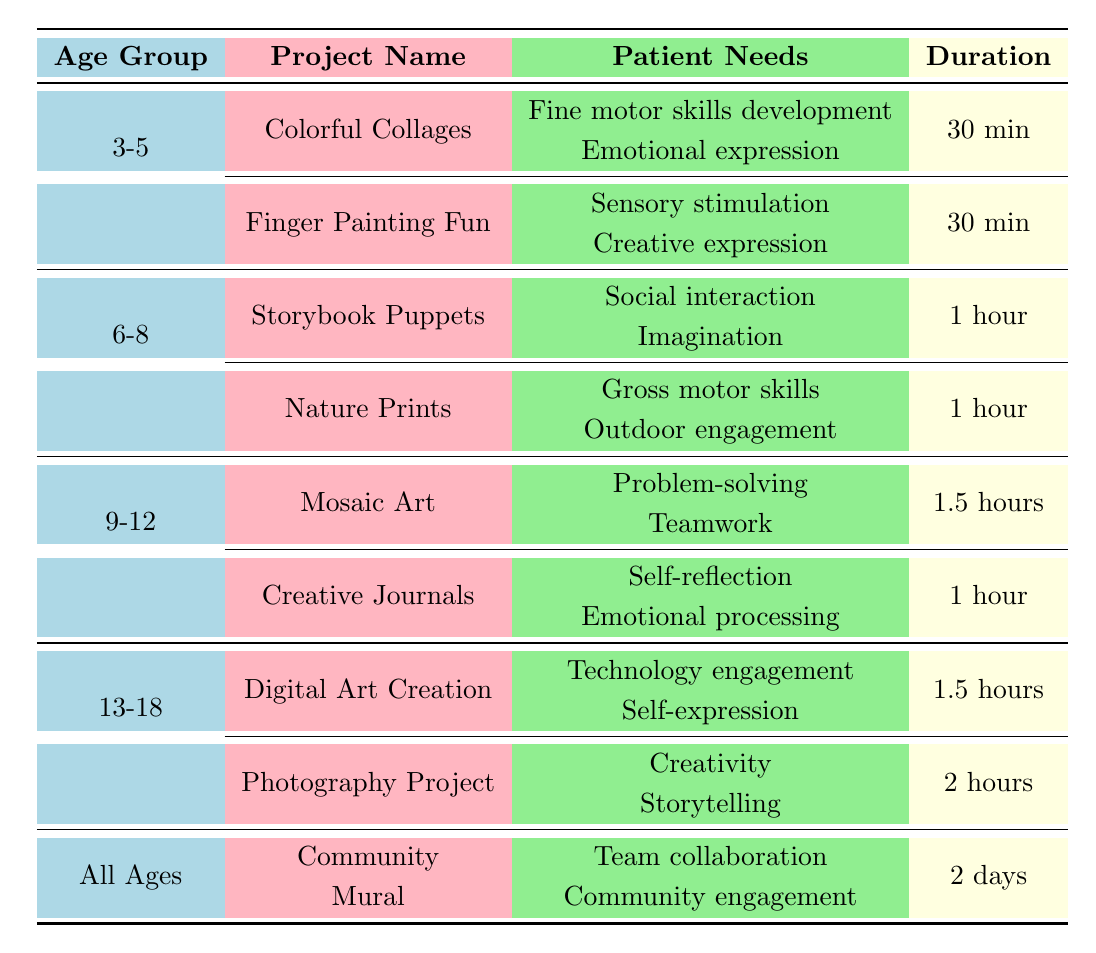What art project is designed for children aged 3-5? The table lists two art projects for the age group 3-5: "Colorful Collages" and "Finger Painting Fun."
Answer: Colorful Collages and Finger Painting Fun What materials are needed for the "Mosaic Art" project? According to the table, the materials for "Mosaic Art" include colored paper, scissors, glue, and baseboards.
Answer: Colored paper, scissors, glue, baseboards How long does the "Photography Project" take to complete? The table specifies that the "Photography Project" takes 2 hours to complete.
Answer: 2 hours Are there any projects aiming for self-reflection among patients aged 9-12? The table indicates that the "Creative Journals" project aims for self-reflection among 9-12 age group patients.
Answer: Yes Which age group has a project focusing on social interaction? The "Storybook Puppets" project is focused on social interaction and is designed for children aged 6-8, as per the table.
Answer: 6-8 How many projects are planned for the age group 3-5? There are two projects listed for the age group 3-5: "Colorful Collages" and "Finger Painting Fun." Thus, the total is 2.
Answer: 2 Does the "Community Mural" project involve collaboration? Yes, the "Community Mural" project is aimed at team collaboration, according to the needs listed in the table.
Answer: Yes What is the total duration for to complete all projects for the 13-18 age group? The project durations for the 13-18 age group are 1.5 hours for "Digital Art Creation" and 2 hours for the "Photography Project." Total duration is 1.5 + 2 = 3.5 hours.
Answer: 3.5 hours Which project requires the longest duration and how long is it? The "Community Mural" project requires the longest duration of 2 days.
Answer: Community Mural, 2 days Is there a project that addresses both emotional expression and fine motor skills development? Yes, "Colorful Collages" addresses both emotional expression and fine motor skills development according to the patient needs specified in the table.
Answer: Yes 